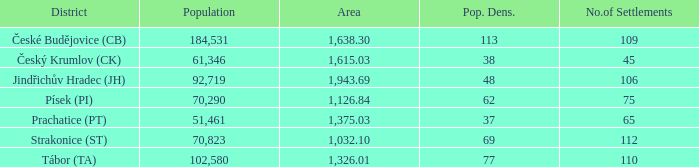What is the size of the region with a population density of 113 and a total population exceeding 184,531? 0.0. Help me parse the entirety of this table. {'header': ['District', 'Population', 'Area', 'Pop. Dens.', 'No.of Settlements'], 'rows': [['České Budějovice (CB)', '184,531', '1,638.30', '113', '109'], ['Český Krumlov (CK)', '61,346', '1,615.03', '38', '45'], ['Jindřichův Hradec (JH)', '92,719', '1,943.69', '48', '106'], ['Písek (PI)', '70,290', '1,126.84', '62', '75'], ['Prachatice (PT)', '51,461', '1,375.03', '37', '65'], ['Strakonice (ST)', '70,823', '1,032.10', '69', '112'], ['Tábor (TA)', '102,580', '1,326.01', '77', '110']]} 